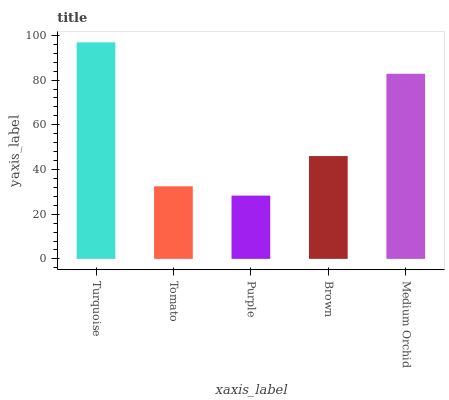Is Purple the minimum?
Answer yes or no. Yes. Is Turquoise the maximum?
Answer yes or no. Yes. Is Tomato the minimum?
Answer yes or no. No. Is Tomato the maximum?
Answer yes or no. No. Is Turquoise greater than Tomato?
Answer yes or no. Yes. Is Tomato less than Turquoise?
Answer yes or no. Yes. Is Tomato greater than Turquoise?
Answer yes or no. No. Is Turquoise less than Tomato?
Answer yes or no. No. Is Brown the high median?
Answer yes or no. Yes. Is Brown the low median?
Answer yes or no. Yes. Is Tomato the high median?
Answer yes or no. No. Is Turquoise the low median?
Answer yes or no. No. 